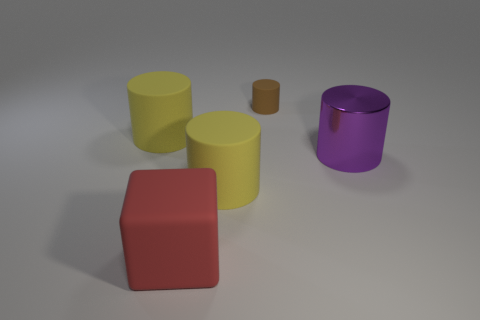There is a cylinder that is both behind the purple cylinder and on the right side of the red thing; how big is it?
Give a very brief answer. Small. What is the color of the thing that is both in front of the large purple cylinder and behind the large red matte block?
Offer a very short reply. Yellow. What is the material of the cylinder on the right side of the rubber cylinder that is behind the big matte thing that is behind the purple object?
Offer a very short reply. Metal. What material is the purple object?
Your response must be concise. Metal. What size is the purple object that is the same shape as the brown object?
Your answer should be very brief. Large. Do the large block and the small cylinder have the same color?
Give a very brief answer. No. What number of other objects are there of the same material as the small brown thing?
Offer a very short reply. 3. Is the number of big purple metallic things that are behind the tiny brown matte cylinder the same as the number of small brown balls?
Your answer should be very brief. Yes. Does the brown object behind the purple metallic object have the same size as the big red rubber thing?
Ensure brevity in your answer.  No. There is a shiny thing; what number of purple metal things are in front of it?
Offer a terse response. 0. 